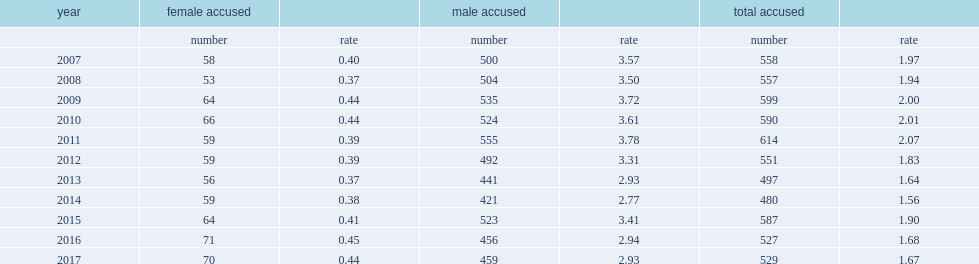According to the homicide survey, how many females are accused of homicide from 2007 to 2017? 679. What is the average number of females accused of homicide from 2007 to 2017 per year? 61.727273. What is te average number of males accused of homicide from 2007 to 2017 per year? 491.818182. What is the average rate of females accused of homicide from 2007 to 2017? 0.407273. 